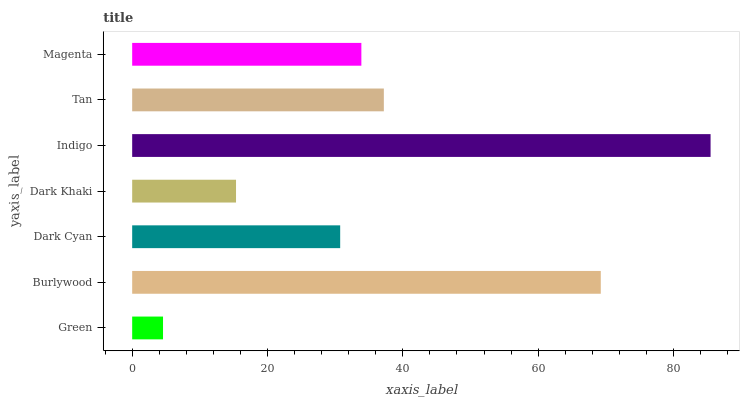Is Green the minimum?
Answer yes or no. Yes. Is Indigo the maximum?
Answer yes or no. Yes. Is Burlywood the minimum?
Answer yes or no. No. Is Burlywood the maximum?
Answer yes or no. No. Is Burlywood greater than Green?
Answer yes or no. Yes. Is Green less than Burlywood?
Answer yes or no. Yes. Is Green greater than Burlywood?
Answer yes or no. No. Is Burlywood less than Green?
Answer yes or no. No. Is Magenta the high median?
Answer yes or no. Yes. Is Magenta the low median?
Answer yes or no. Yes. Is Indigo the high median?
Answer yes or no. No. Is Burlywood the low median?
Answer yes or no. No. 